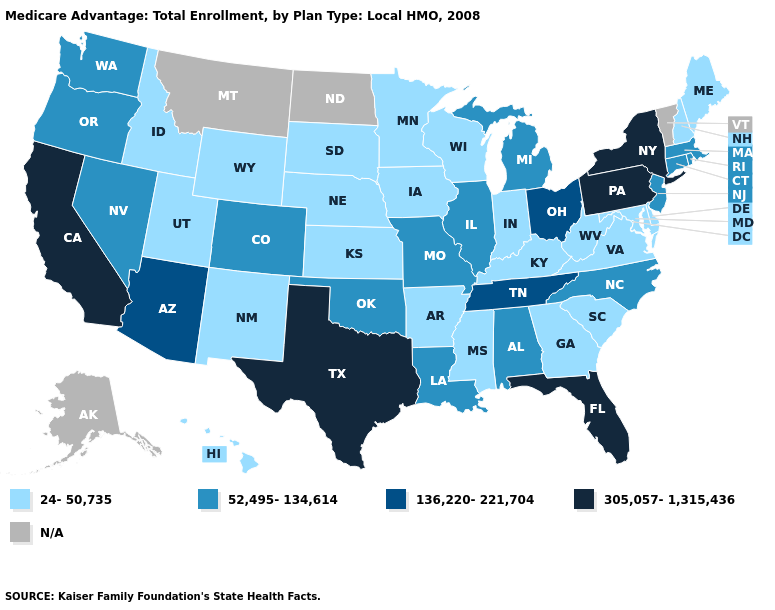Name the states that have a value in the range 52,495-134,614?
Quick response, please. Alabama, Colorado, Connecticut, Illinois, Louisiana, Massachusetts, Michigan, Missouri, North Carolina, New Jersey, Nevada, Oklahoma, Oregon, Rhode Island, Washington. What is the highest value in the USA?
Concise answer only. 305,057-1,315,436. Does Massachusetts have the highest value in the USA?
Quick response, please. No. Which states have the lowest value in the West?
Write a very short answer. Hawaii, Idaho, New Mexico, Utah, Wyoming. Name the states that have a value in the range 52,495-134,614?
Write a very short answer. Alabama, Colorado, Connecticut, Illinois, Louisiana, Massachusetts, Michigan, Missouri, North Carolina, New Jersey, Nevada, Oklahoma, Oregon, Rhode Island, Washington. Does Missouri have the lowest value in the USA?
Short answer required. No. Name the states that have a value in the range 24-50,735?
Keep it brief. Arkansas, Delaware, Georgia, Hawaii, Iowa, Idaho, Indiana, Kansas, Kentucky, Maryland, Maine, Minnesota, Mississippi, Nebraska, New Hampshire, New Mexico, South Carolina, South Dakota, Utah, Virginia, Wisconsin, West Virginia, Wyoming. Name the states that have a value in the range 136,220-221,704?
Keep it brief. Arizona, Ohio, Tennessee. Name the states that have a value in the range 136,220-221,704?
Short answer required. Arizona, Ohio, Tennessee. Does the first symbol in the legend represent the smallest category?
Give a very brief answer. Yes. Among the states that border Arizona , does California have the highest value?
Keep it brief. Yes. Name the states that have a value in the range N/A?
Be succinct. Alaska, Montana, North Dakota, Vermont. Name the states that have a value in the range 52,495-134,614?
Answer briefly. Alabama, Colorado, Connecticut, Illinois, Louisiana, Massachusetts, Michigan, Missouri, North Carolina, New Jersey, Nevada, Oklahoma, Oregon, Rhode Island, Washington. Name the states that have a value in the range 24-50,735?
Answer briefly. Arkansas, Delaware, Georgia, Hawaii, Iowa, Idaho, Indiana, Kansas, Kentucky, Maryland, Maine, Minnesota, Mississippi, Nebraska, New Hampshire, New Mexico, South Carolina, South Dakota, Utah, Virginia, Wisconsin, West Virginia, Wyoming. 